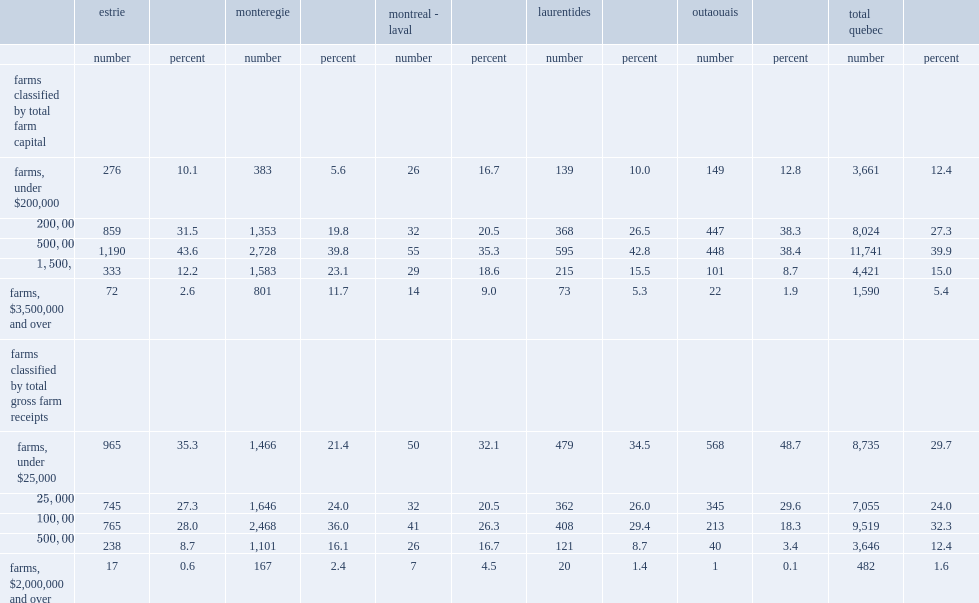What regions are more likely to have higher farm capital value($1,500,000 and up) compared to all farms in quebec? Monteregie montreal - laval. 